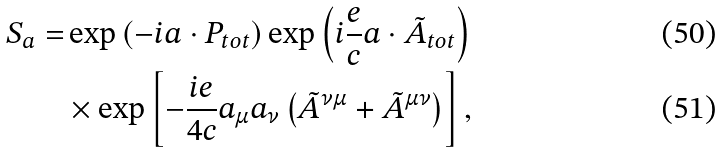Convert formula to latex. <formula><loc_0><loc_0><loc_500><loc_500>S _ { a } = & \exp \left ( - i { a } \cdot { P } _ { t o t } \right ) \exp \left ( i \frac { e } { c } { a } \cdot { \tilde { A } } _ { t o t } \right ) \\ & \times \exp \left [ - \frac { i e } { 4 c } a _ { \mu } a _ { \nu } \left ( \tilde { A } ^ { \nu \mu } + \tilde { A } ^ { \mu \nu } \right ) \right ] ,</formula> 